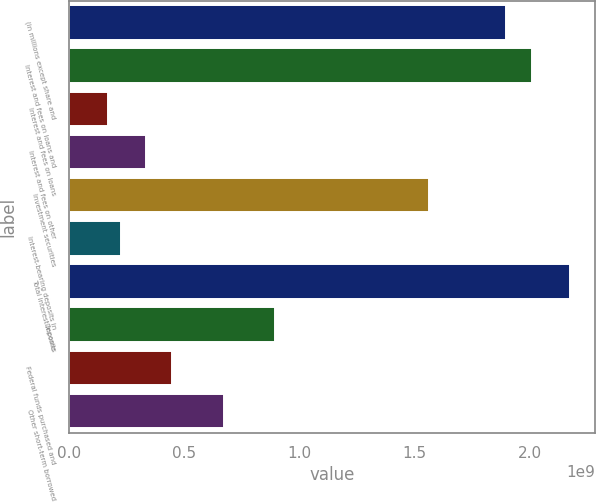<chart> <loc_0><loc_0><loc_500><loc_500><bar_chart><fcel>(in millions except share and<fcel>Interest and fees on loans and<fcel>Interest and fees on loans<fcel>Interest and fees on other<fcel>Investment securities<fcel>Interest-bearing deposits in<fcel>Total interest income<fcel>Deposits<fcel>Federal funds purchased and<fcel>Other short-term borrowed<nl><fcel>1.89626e+09<fcel>2.00781e+09<fcel>1.67317e+08<fcel>3.34635e+08<fcel>1.56163e+09<fcel>2.2309e+08<fcel>2.17513e+09<fcel>8.9236e+08<fcel>4.4618e+08<fcel>6.6927e+08<nl></chart> 